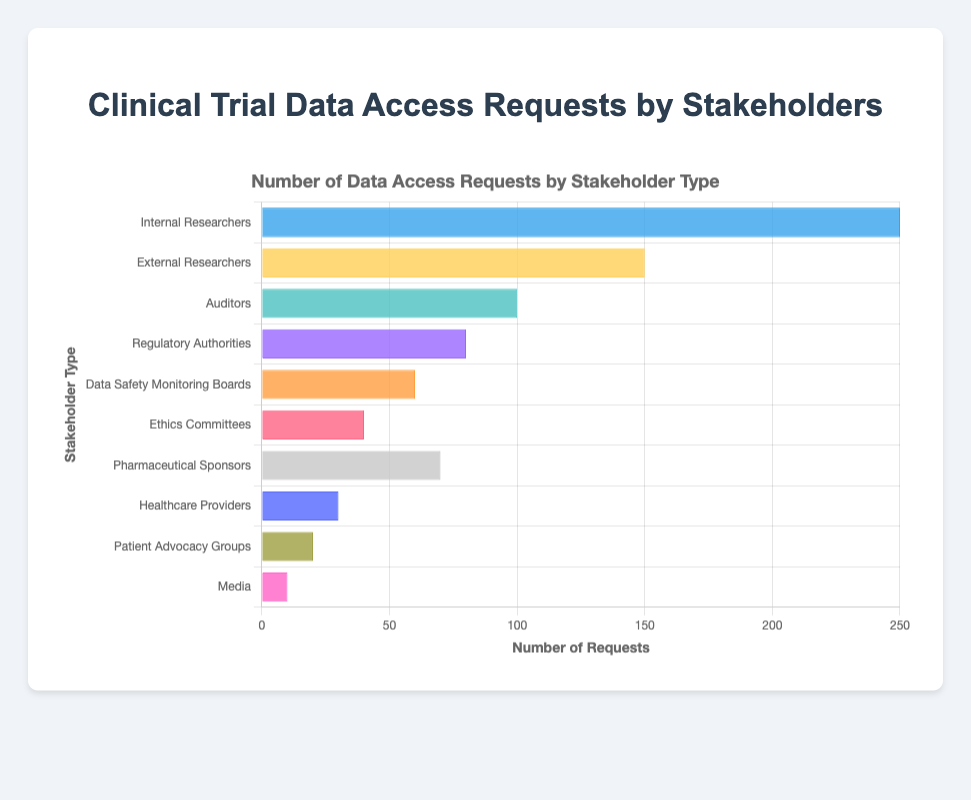What's the total number of data access requests? To find the total, sum all the data access requests: 250 (Internal Researchers) + 150 (External Researchers) + 100 (Auditors) + 80 (Regulatory Authorities) + 60 (Data Safety Monitoring Boards) + 40 (Ethics Committees) + 70 (Pharmaceutical Sponsors) + 30 (Healthcare Providers) + 20 (Patient Advocacy Groups) + 10 (Media) = 810
Answer: 810 Which stakeholder has the highest number of data access requests? Compare the values: Internal Researchers (250), External Researchers (150), Auditors (100), Regulatory Authorities (80), Data Safety Monitoring Boards (60), Ethics Committees (40), Pharmaceutical Sponsors (70), Healthcare Providers (30), Patient Advocacy Groups (20), and Media (10). The highest is 250
Answer: Internal Researchers How many more data access requests do Internal Researchers have than Auditors? Subtract the number of requests by Auditors from Internal Researchers: 250 (Internal Researchers) - 100 (Auditors) = 150
Answer: 150 What is the average number of data access requests across all stakeholders? Sum all the data access requests (810) and divide by the number of stakeholders (10): 810 / 10 = 81
Answer: 81 Which three stakeholders have the lowest number of data access requests? Sort the requests: Media (10), Patient Advocacy Groups (20), Healthcare Providers (30), Ethics Committees (40), Data Safety Monitoring Boards (60), Regulatory Authorities (80), Pharmaceutical Sponsors (70), Auditors (100), External Researchers (150), Internal Researchers (250). The lowest three are Media, Patient Advocacy Groups, and Healthcare Providers
Answer: Media, Patient Advocacy Groups, Healthcare Providers Is the number of data access requests by External Researchers greater than the sum of requests by Healthcare Providers and Patient Advocacy Groups? Sum the requests by Healthcare Providers (30) and Patient Advocacy Groups (20) and compare with External Researchers: 30 + 20 = 50; 150 (External Researchers) > 50
Answer: Yes Which stakeholder category has a number of requests closest to the average number of requests? The average is 81. Compare to stakeholders' requests: Internal Researchers (250), External Researchers (150), Auditors (100), Regulatory Authorities (80), Data Safety Monitoring Boards (60), Ethics Committees (40), Pharmaceutical Sponsors (70), Healthcare Providers (30), Patient Advocacy Groups (20), Media (10). The closest to 81 is Regulatory Authorities (80)
Answer: Regulatory Authorities By how much do the combined requests of Internal and External Researchers exceed the combined requests of Auditors and Regulatory Authorities? Sum the requests: Internal Researchers (250) + External Researchers (150) = 400, and Auditors (100) + Regulatory Authorities (80) = 180. Subtract the smaller sum from the larger sum: 400 - 180 = 220
Answer: 220 What is the difference in the number of data access requests between Data Safety Monitoring Boards and Pharmaceutical Sponsors? Subtract the number of requests by Data Safety Monitoring Boards from Pharmaceutical Sponsors: 70 (Pharmaceutical Sponsors) - 60 (Data Safety Monitoring Boards) = 10
Answer: 10 How does the number of data access requests by Ethics Committees compare to that by Healthcare Providers? Ethics Committees (40) have more requests than Healthcare Providers (30)
Answer: More 